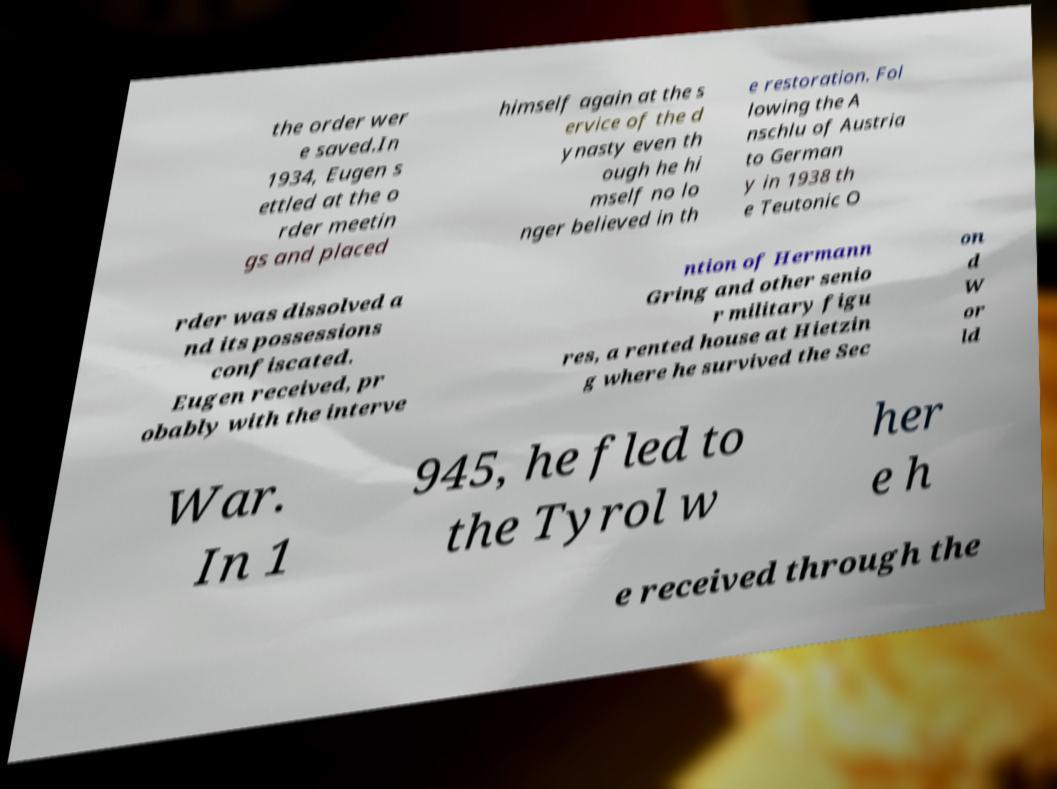Please identify and transcribe the text found in this image. the order wer e saved.In 1934, Eugen s ettled at the o rder meetin gs and placed himself again at the s ervice of the d ynasty even th ough he hi mself no lo nger believed in th e restoration. Fol lowing the A nschlu of Austria to German y in 1938 th e Teutonic O rder was dissolved a nd its possessions confiscated. Eugen received, pr obably with the interve ntion of Hermann Gring and other senio r military figu res, a rented house at Hietzin g where he survived the Sec on d W or ld War. In 1 945, he fled to the Tyrol w her e h e received through the 